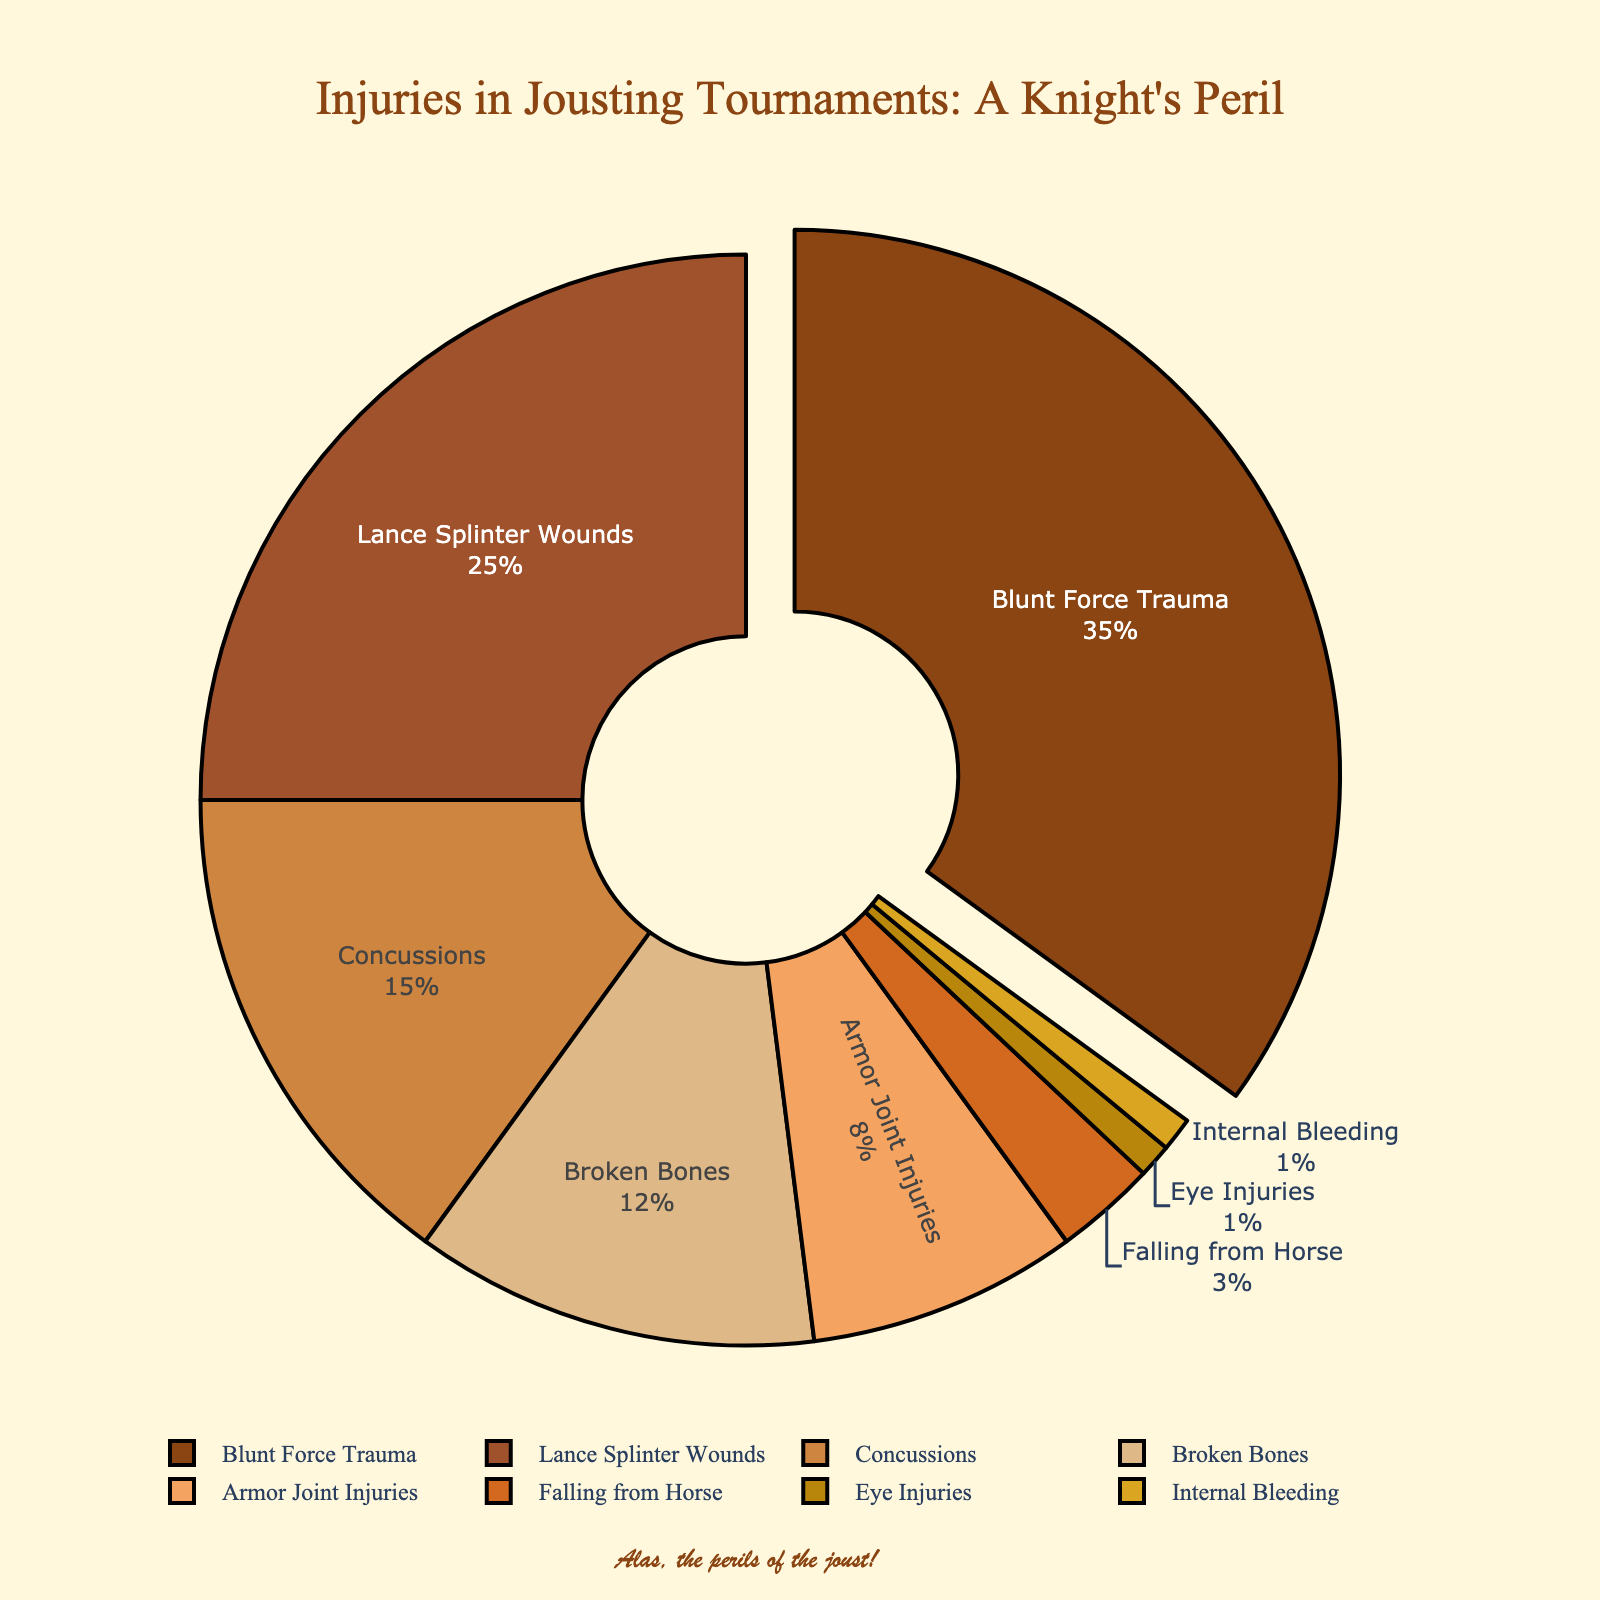What percentage of injuries are due to Blunt Force Trauma? The pie chart labels show "Blunt Force Trauma" as one of the injury types. According to the chart, Blunt Force Trauma accounts for 35% of injuries.
Answer: 35% What is the combined percentage of Concussions and Broken Bones injuries? To find the combined percentage, add the percentages of Concussions (15%) and Broken Bones (12%). The sum is 15% + 12% = 27%.
Answer: 27% Which type of injury is the least common in jousting tournaments? The pie chart labels all injury types with their respective percentages. Eye Injuries and Internal Bleeding both have the lowest percentage at 1% each.
Answer: Eye Injuries and Internal Bleeding Which injury type has a higher percentage: Lance Splinter Wounds or Armor Joint Injuries? Compare the percentages shown on the chart: Lance Splinter Wounds are at 25% and Armor Joint Injuries are at 8%. Since 25% is greater than 8%, Lance Splinter Wounds have a higher percentage.
Answer: Lance Splinter Wounds What is the difference in percentage between Blunt Force Trauma and Falling from Horse injuries? To find the difference, subtract the percentage of Falling from Horse (3%) from Blunt Force Trauma (35%). The difference is 35% - 3% = 32%.
Answer: 32% What is the total percentage for injuries associated with blunt force, such as Blunt Force Trauma and Concussions? Add the percentages of Blunt Force Trauma (35%) and Concussions (15%). The total is 35% + 15% = 50%.
Answer: 50% By how many percentage points do Lance Splinter Wounds exceed the combined percentages of Eye Injuries and Internal Bleeding? First, find the combined percentage of Eye Injuries (1%) and Internal Bleeding (1%), which is 1% + 1% = 2%. Then, subtract this combined percentage from the percentage of Lance Splinter Wounds (25%). The result is 25% - 2% = 23%.
Answer: 23% What injuries account for less than 5% of the total injuries? Find the injury types with percentages less than 5% according to the chart: Falling from Horse (3%), Eye Injuries (1%), and Internal Bleeding (1%).
Answer: Falling from Horse, Eye Injuries, Internal Bleeding 